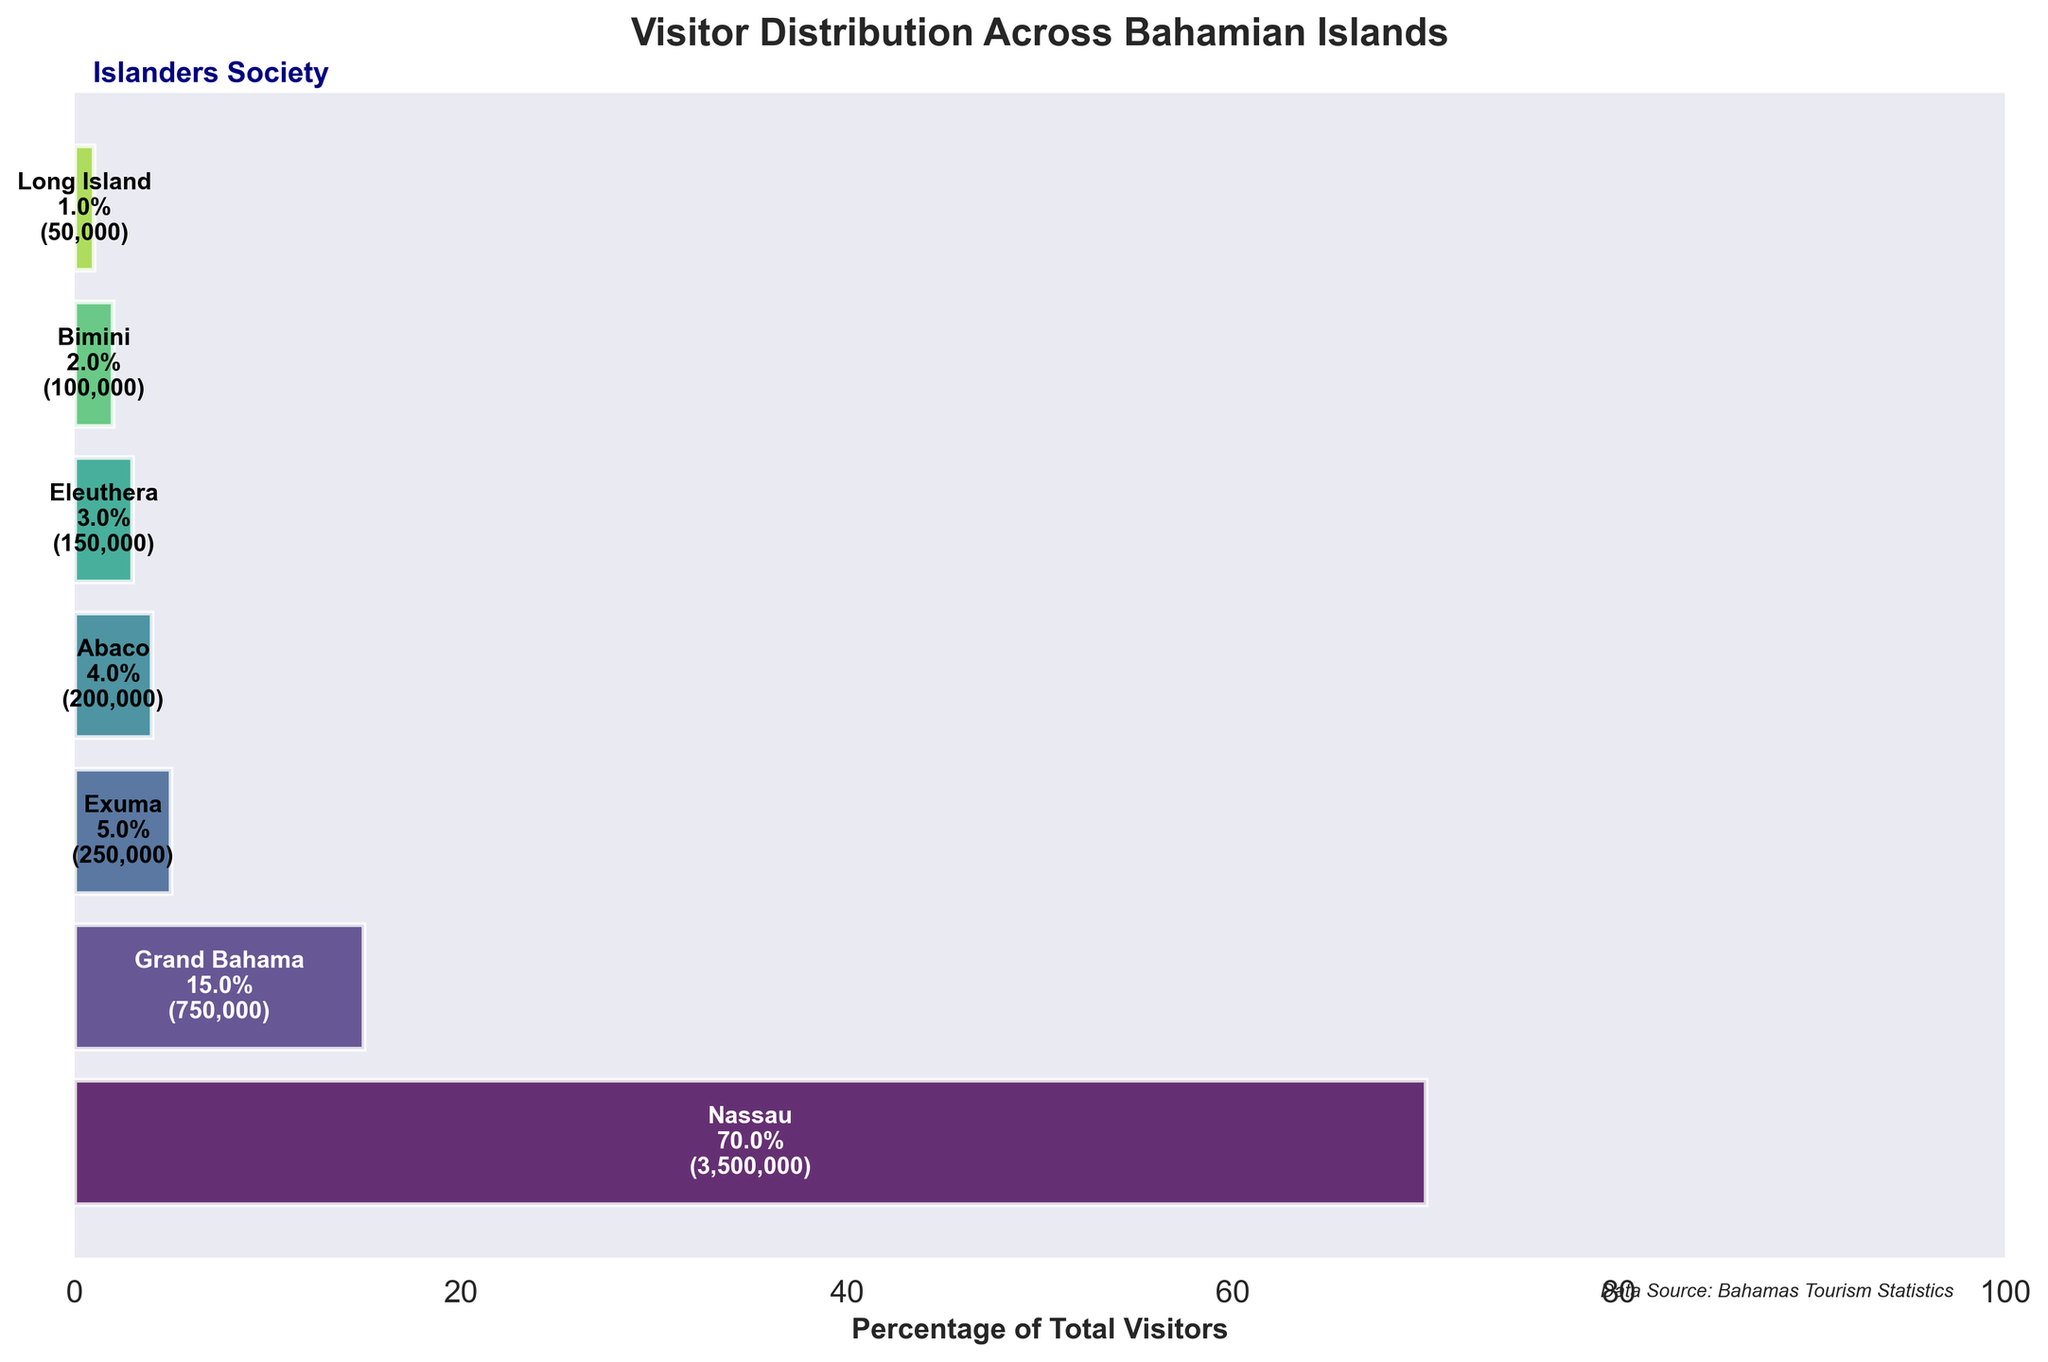What is the title of the funnel chart? The title typically appears at the top of the chart, summarizing its content. Here, the title is explicitly shown.
Answer: Visitor Distribution Across Bahamian Islands How many islands are displayed in the funnel chart? By counting the distinct bars or segments in the funnel chart, you can determine the number of islands.
Answer: 7 Which island receives the highest number of visitors? The highest number of visitors can be identified by looking at the widest bar at the top of the funnel.
Answer: Nassau What percentage of visitors goes to Grand Bahama? The percentage is marked within the respective bar segment representing Grand Bahama.
Answer: 17.1% What is the total number of visitors to the Bahamas as shown in the chart? To find the total, add all the visitor counts from each island. 3,500,000 (Nassau) + 750,000 (Grand Bahama) + 250,000 (Exuma) + 200,000 (Abaco) + 150,000 (Eleuthera) + 100,000 (Bimini) + 50,000 (Long Island) = 5,000,000
Answer: 5,000,000 Which island has fewer visitors, Abaco or Eleuthera? By comparing the visitor numbers displayed within the bars for Abaco and Eleuthera, it becomes clear which is smaller.
Answer: Eleuthera What is the combined percentage of visitors to Exuma and Abaco? Sum the individual percentages for Exuma and Abaco. Exuma: 5%, Abaco: 4%, then 5% + 4% = 9%
Answer: 9% How does the visitor percentage for Bimini compare to that for Long Island? Examine and compare the percentage labels within the respective bar segments for Bimini and Long Island.
Answer: Bimini has 2% and Long Island has 1%; Bimini has a higher percentage What is the visitor difference between the island with the most visitors and the island with the least visitors? Subtract the number of visitors to Long Island (50,000) from the number of visitors to Nassau (3,500,000). 3,500,000 - 50,000 = 3,450,000
Answer: 3,450,000 What's the average number of visitors per island in the chart? Divide the total number of visitors by the number of islands. 5,000,000 / 7 ≈ 714,286
Answer: 714,286 